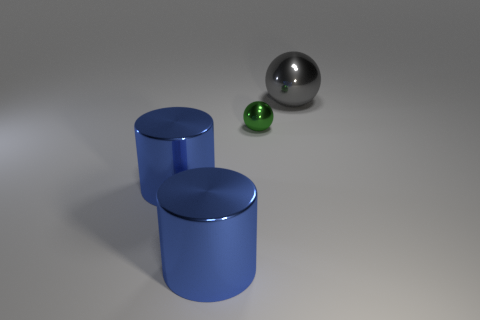There is a big thing that is behind the metal ball on the left side of the metallic ball that is on the right side of the tiny green metallic sphere; what is its shape?
Your response must be concise. Sphere. Are there any other things that are the same size as the green sphere?
Offer a terse response. No. What number of spheres are either large things or tiny green metallic things?
Offer a very short reply. 2. Is the material of the gray thing the same as the green object?
Offer a very short reply. Yes. What number of other objects are the same color as the small thing?
Your response must be concise. 0. There is a metal thing behind the small green thing; what is its shape?
Ensure brevity in your answer.  Sphere. What number of things are either blue cubes or gray spheres?
Keep it short and to the point. 1. Do the green metal object and the thing that is behind the green metal sphere have the same size?
Your answer should be compact. No. What number of other things are there of the same material as the small sphere
Offer a very short reply. 3. How many objects are either shiny objects right of the tiny green shiny ball or large metallic cylinders that are in front of the big shiny ball?
Keep it short and to the point. 3. 